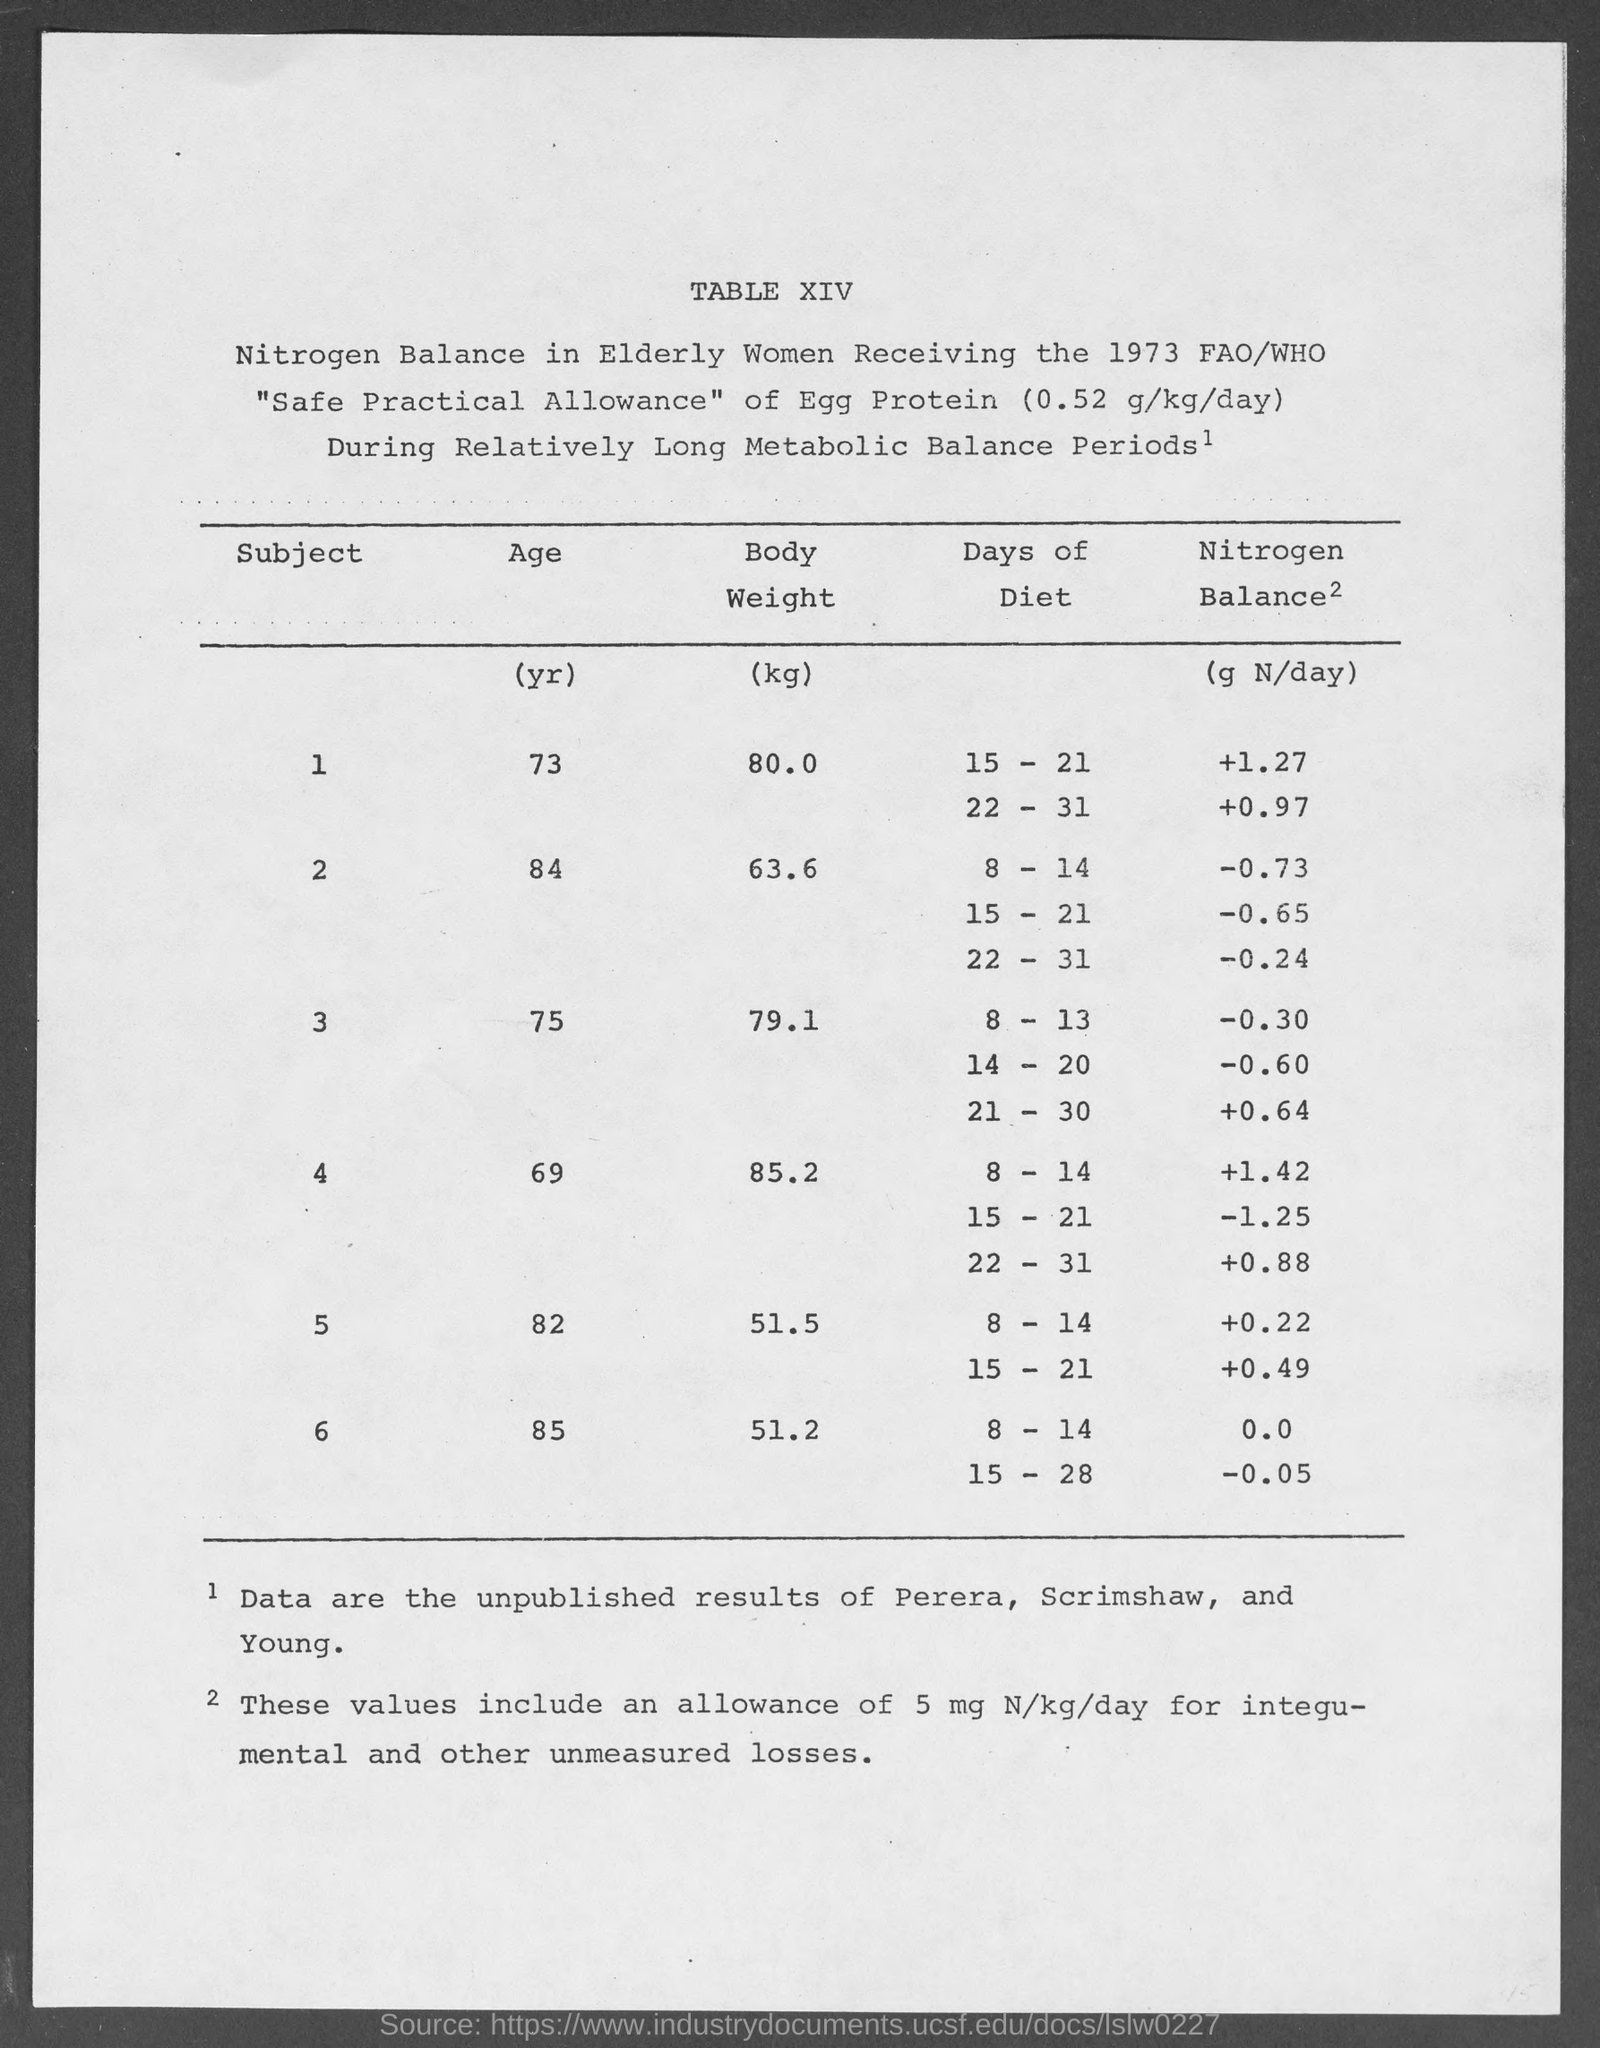Highlight a few significant elements in this photo. According to the given table, the body weight for a person of 73 years of age is 80.0 kilograms. According to the given table, the average body weight for a 69-year-old individual is 85.2 kilograms. The estimated body weight for a person aged 82 years, according to the given table, is 51.5 kilograms. According to the given table, the body weight for a person who is 84 years old is 63.6 kilograms. The body weight for a 75-year-old individual is 79.1 kilograms, as mentioned in the given table. 